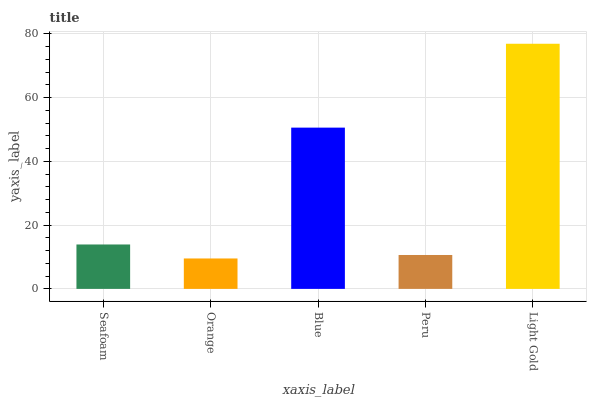Is Orange the minimum?
Answer yes or no. Yes. Is Light Gold the maximum?
Answer yes or no. Yes. Is Blue the minimum?
Answer yes or no. No. Is Blue the maximum?
Answer yes or no. No. Is Blue greater than Orange?
Answer yes or no. Yes. Is Orange less than Blue?
Answer yes or no. Yes. Is Orange greater than Blue?
Answer yes or no. No. Is Blue less than Orange?
Answer yes or no. No. Is Seafoam the high median?
Answer yes or no. Yes. Is Seafoam the low median?
Answer yes or no. Yes. Is Peru the high median?
Answer yes or no. No. Is Peru the low median?
Answer yes or no. No. 